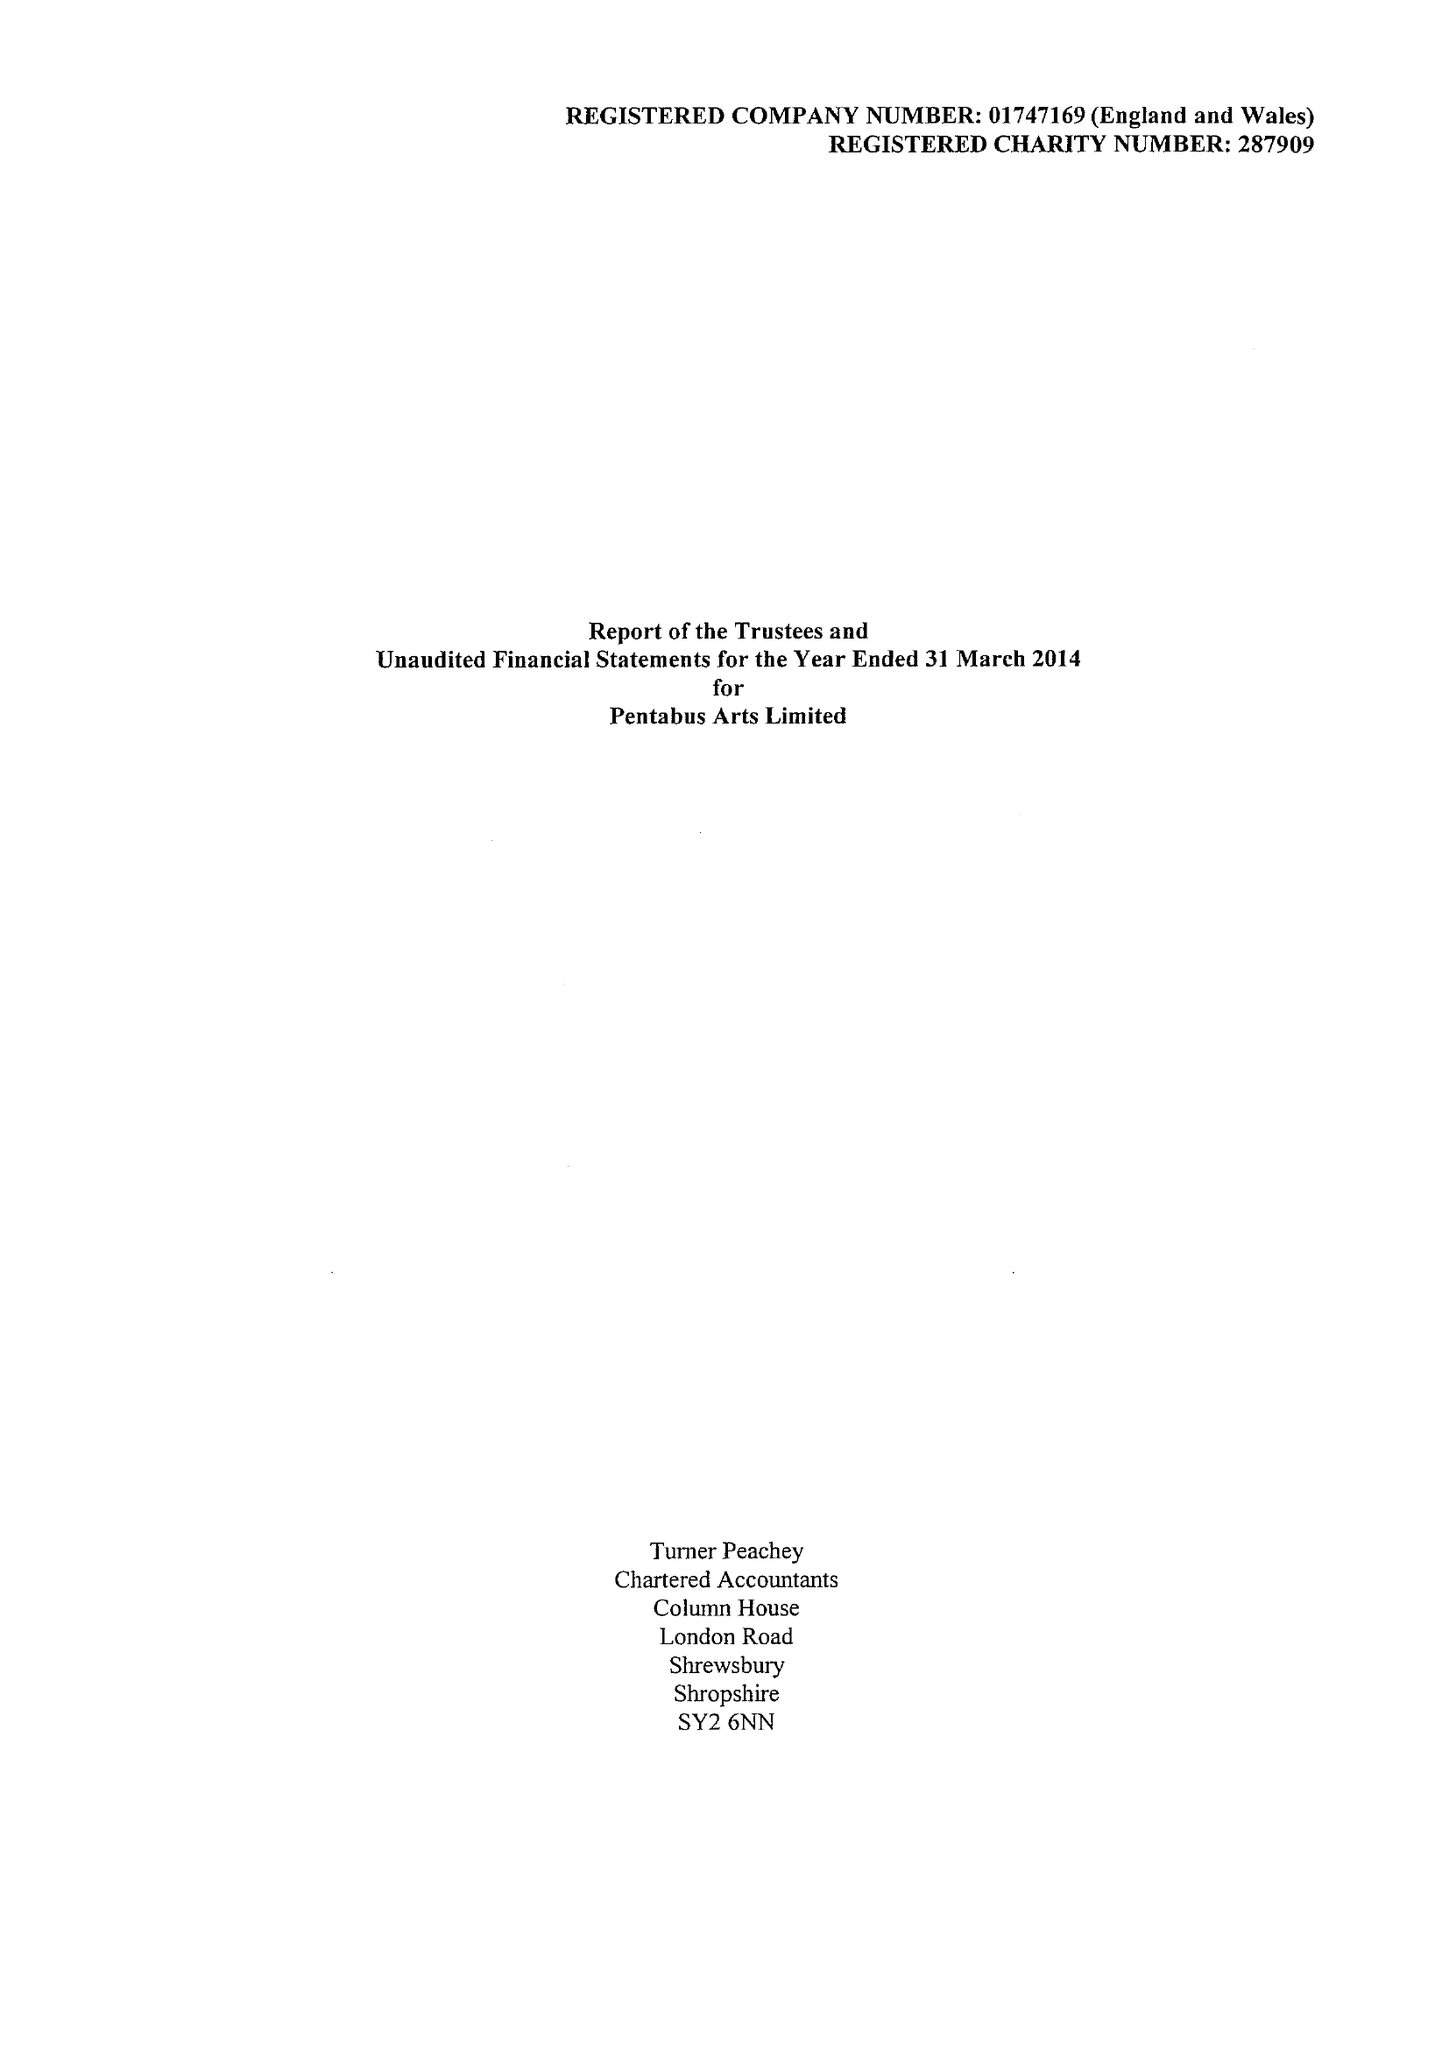What is the value for the address__postcode?
Answer the question using a single word or phrase. SY8 2JU 